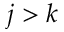<formula> <loc_0><loc_0><loc_500><loc_500>j > k</formula> 